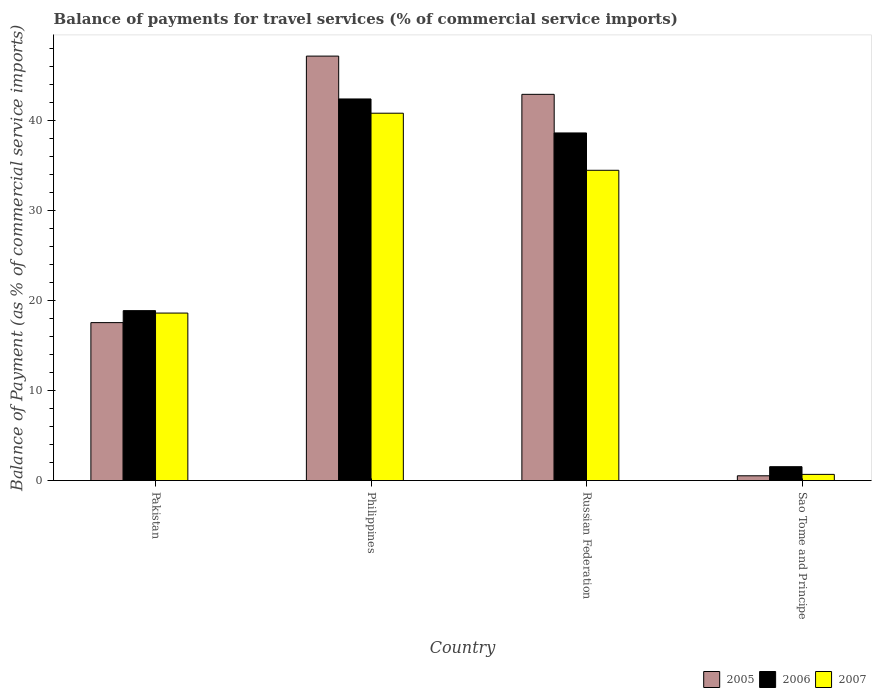How many different coloured bars are there?
Provide a short and direct response. 3. How many groups of bars are there?
Ensure brevity in your answer.  4. How many bars are there on the 4th tick from the left?
Offer a very short reply. 3. What is the label of the 1st group of bars from the left?
Give a very brief answer. Pakistan. In how many cases, is the number of bars for a given country not equal to the number of legend labels?
Your answer should be compact. 0. What is the balance of payments for travel services in 2007 in Russian Federation?
Ensure brevity in your answer.  34.5. Across all countries, what is the maximum balance of payments for travel services in 2007?
Ensure brevity in your answer.  40.84. Across all countries, what is the minimum balance of payments for travel services in 2006?
Keep it short and to the point. 1.54. In which country was the balance of payments for travel services in 2006 maximum?
Your answer should be very brief. Philippines. In which country was the balance of payments for travel services in 2007 minimum?
Make the answer very short. Sao Tome and Principe. What is the total balance of payments for travel services in 2005 in the graph?
Make the answer very short. 108.24. What is the difference between the balance of payments for travel services in 2006 in Pakistan and that in Sao Tome and Principe?
Ensure brevity in your answer.  17.35. What is the difference between the balance of payments for travel services in 2005 in Sao Tome and Principe and the balance of payments for travel services in 2006 in Russian Federation?
Your answer should be very brief. -38.12. What is the average balance of payments for travel services in 2006 per country?
Your answer should be compact. 25.38. What is the difference between the balance of payments for travel services of/in 2005 and balance of payments for travel services of/in 2006 in Sao Tome and Principe?
Make the answer very short. -1.01. What is the ratio of the balance of payments for travel services in 2005 in Philippines to that in Sao Tome and Principe?
Provide a short and direct response. 88.75. Is the balance of payments for travel services in 2007 in Russian Federation less than that in Sao Tome and Principe?
Your answer should be compact. No. What is the difference between the highest and the second highest balance of payments for travel services in 2007?
Your answer should be compact. 6.35. What is the difference between the highest and the lowest balance of payments for travel services in 2006?
Your answer should be compact. 40.89. Is the sum of the balance of payments for travel services in 2007 in Pakistan and Sao Tome and Principe greater than the maximum balance of payments for travel services in 2005 across all countries?
Offer a very short reply. No. Is it the case that in every country, the sum of the balance of payments for travel services in 2007 and balance of payments for travel services in 2005 is greater than the balance of payments for travel services in 2006?
Provide a short and direct response. No. How many bars are there?
Ensure brevity in your answer.  12. How many countries are there in the graph?
Provide a short and direct response. 4. Does the graph contain any zero values?
Your answer should be very brief. No. Does the graph contain grids?
Ensure brevity in your answer.  No. How many legend labels are there?
Keep it short and to the point. 3. How are the legend labels stacked?
Keep it short and to the point. Horizontal. What is the title of the graph?
Give a very brief answer. Balance of payments for travel services (% of commercial service imports). What is the label or title of the X-axis?
Offer a terse response. Country. What is the label or title of the Y-axis?
Offer a very short reply. Balance of Payment (as % of commercial service imports). What is the Balance of Payment (as % of commercial service imports) of 2005 in Pakistan?
Your answer should be very brief. 17.56. What is the Balance of Payment (as % of commercial service imports) in 2006 in Pakistan?
Give a very brief answer. 18.89. What is the Balance of Payment (as % of commercial service imports) in 2007 in Pakistan?
Provide a short and direct response. 18.62. What is the Balance of Payment (as % of commercial service imports) in 2005 in Philippines?
Your response must be concise. 47.2. What is the Balance of Payment (as % of commercial service imports) in 2006 in Philippines?
Your answer should be very brief. 42.43. What is the Balance of Payment (as % of commercial service imports) in 2007 in Philippines?
Keep it short and to the point. 40.84. What is the Balance of Payment (as % of commercial service imports) of 2005 in Russian Federation?
Your response must be concise. 42.94. What is the Balance of Payment (as % of commercial service imports) of 2006 in Russian Federation?
Make the answer very short. 38.65. What is the Balance of Payment (as % of commercial service imports) of 2007 in Russian Federation?
Provide a succinct answer. 34.5. What is the Balance of Payment (as % of commercial service imports) in 2005 in Sao Tome and Principe?
Offer a very short reply. 0.53. What is the Balance of Payment (as % of commercial service imports) in 2006 in Sao Tome and Principe?
Provide a short and direct response. 1.54. What is the Balance of Payment (as % of commercial service imports) in 2007 in Sao Tome and Principe?
Provide a short and direct response. 0.69. Across all countries, what is the maximum Balance of Payment (as % of commercial service imports) in 2005?
Keep it short and to the point. 47.2. Across all countries, what is the maximum Balance of Payment (as % of commercial service imports) in 2006?
Make the answer very short. 42.43. Across all countries, what is the maximum Balance of Payment (as % of commercial service imports) of 2007?
Offer a very short reply. 40.84. Across all countries, what is the minimum Balance of Payment (as % of commercial service imports) of 2005?
Offer a terse response. 0.53. Across all countries, what is the minimum Balance of Payment (as % of commercial service imports) of 2006?
Make the answer very short. 1.54. Across all countries, what is the minimum Balance of Payment (as % of commercial service imports) of 2007?
Offer a terse response. 0.69. What is the total Balance of Payment (as % of commercial service imports) of 2005 in the graph?
Ensure brevity in your answer.  108.23. What is the total Balance of Payment (as % of commercial service imports) in 2006 in the graph?
Offer a very short reply. 101.52. What is the total Balance of Payment (as % of commercial service imports) in 2007 in the graph?
Your response must be concise. 94.66. What is the difference between the Balance of Payment (as % of commercial service imports) in 2005 in Pakistan and that in Philippines?
Provide a succinct answer. -29.63. What is the difference between the Balance of Payment (as % of commercial service imports) of 2006 in Pakistan and that in Philippines?
Keep it short and to the point. -23.54. What is the difference between the Balance of Payment (as % of commercial service imports) in 2007 in Pakistan and that in Philippines?
Offer a very short reply. -22.22. What is the difference between the Balance of Payment (as % of commercial service imports) in 2005 in Pakistan and that in Russian Federation?
Your response must be concise. -25.38. What is the difference between the Balance of Payment (as % of commercial service imports) of 2006 in Pakistan and that in Russian Federation?
Provide a short and direct response. -19.76. What is the difference between the Balance of Payment (as % of commercial service imports) in 2007 in Pakistan and that in Russian Federation?
Your answer should be compact. -15.88. What is the difference between the Balance of Payment (as % of commercial service imports) of 2005 in Pakistan and that in Sao Tome and Principe?
Give a very brief answer. 17.03. What is the difference between the Balance of Payment (as % of commercial service imports) of 2006 in Pakistan and that in Sao Tome and Principe?
Provide a short and direct response. 17.35. What is the difference between the Balance of Payment (as % of commercial service imports) in 2007 in Pakistan and that in Sao Tome and Principe?
Your response must be concise. 17.94. What is the difference between the Balance of Payment (as % of commercial service imports) in 2005 in Philippines and that in Russian Federation?
Offer a terse response. 4.25. What is the difference between the Balance of Payment (as % of commercial service imports) of 2006 in Philippines and that in Russian Federation?
Make the answer very short. 3.78. What is the difference between the Balance of Payment (as % of commercial service imports) in 2007 in Philippines and that in Russian Federation?
Your answer should be compact. 6.35. What is the difference between the Balance of Payment (as % of commercial service imports) in 2005 in Philippines and that in Sao Tome and Principe?
Keep it short and to the point. 46.66. What is the difference between the Balance of Payment (as % of commercial service imports) in 2006 in Philippines and that in Sao Tome and Principe?
Offer a very short reply. 40.89. What is the difference between the Balance of Payment (as % of commercial service imports) in 2007 in Philippines and that in Sao Tome and Principe?
Keep it short and to the point. 40.16. What is the difference between the Balance of Payment (as % of commercial service imports) in 2005 in Russian Federation and that in Sao Tome and Principe?
Ensure brevity in your answer.  42.41. What is the difference between the Balance of Payment (as % of commercial service imports) of 2006 in Russian Federation and that in Sao Tome and Principe?
Offer a terse response. 37.11. What is the difference between the Balance of Payment (as % of commercial service imports) of 2007 in Russian Federation and that in Sao Tome and Principe?
Ensure brevity in your answer.  33.81. What is the difference between the Balance of Payment (as % of commercial service imports) in 2005 in Pakistan and the Balance of Payment (as % of commercial service imports) in 2006 in Philippines?
Keep it short and to the point. -24.87. What is the difference between the Balance of Payment (as % of commercial service imports) in 2005 in Pakistan and the Balance of Payment (as % of commercial service imports) in 2007 in Philippines?
Make the answer very short. -23.28. What is the difference between the Balance of Payment (as % of commercial service imports) of 2006 in Pakistan and the Balance of Payment (as % of commercial service imports) of 2007 in Philippines?
Keep it short and to the point. -21.95. What is the difference between the Balance of Payment (as % of commercial service imports) in 2005 in Pakistan and the Balance of Payment (as % of commercial service imports) in 2006 in Russian Federation?
Provide a succinct answer. -21.09. What is the difference between the Balance of Payment (as % of commercial service imports) of 2005 in Pakistan and the Balance of Payment (as % of commercial service imports) of 2007 in Russian Federation?
Offer a very short reply. -16.94. What is the difference between the Balance of Payment (as % of commercial service imports) in 2006 in Pakistan and the Balance of Payment (as % of commercial service imports) in 2007 in Russian Federation?
Your answer should be compact. -15.61. What is the difference between the Balance of Payment (as % of commercial service imports) of 2005 in Pakistan and the Balance of Payment (as % of commercial service imports) of 2006 in Sao Tome and Principe?
Your answer should be compact. 16.02. What is the difference between the Balance of Payment (as % of commercial service imports) in 2005 in Pakistan and the Balance of Payment (as % of commercial service imports) in 2007 in Sao Tome and Principe?
Provide a succinct answer. 16.87. What is the difference between the Balance of Payment (as % of commercial service imports) in 2006 in Pakistan and the Balance of Payment (as % of commercial service imports) in 2007 in Sao Tome and Principe?
Provide a succinct answer. 18.21. What is the difference between the Balance of Payment (as % of commercial service imports) in 2005 in Philippines and the Balance of Payment (as % of commercial service imports) in 2006 in Russian Federation?
Your answer should be compact. 8.54. What is the difference between the Balance of Payment (as % of commercial service imports) of 2005 in Philippines and the Balance of Payment (as % of commercial service imports) of 2007 in Russian Federation?
Your answer should be compact. 12.7. What is the difference between the Balance of Payment (as % of commercial service imports) in 2006 in Philippines and the Balance of Payment (as % of commercial service imports) in 2007 in Russian Federation?
Keep it short and to the point. 7.93. What is the difference between the Balance of Payment (as % of commercial service imports) in 2005 in Philippines and the Balance of Payment (as % of commercial service imports) in 2006 in Sao Tome and Principe?
Ensure brevity in your answer.  45.65. What is the difference between the Balance of Payment (as % of commercial service imports) of 2005 in Philippines and the Balance of Payment (as % of commercial service imports) of 2007 in Sao Tome and Principe?
Your response must be concise. 46.51. What is the difference between the Balance of Payment (as % of commercial service imports) in 2006 in Philippines and the Balance of Payment (as % of commercial service imports) in 2007 in Sao Tome and Principe?
Keep it short and to the point. 41.74. What is the difference between the Balance of Payment (as % of commercial service imports) in 2005 in Russian Federation and the Balance of Payment (as % of commercial service imports) in 2006 in Sao Tome and Principe?
Your answer should be compact. 41.4. What is the difference between the Balance of Payment (as % of commercial service imports) in 2005 in Russian Federation and the Balance of Payment (as % of commercial service imports) in 2007 in Sao Tome and Principe?
Offer a terse response. 42.26. What is the difference between the Balance of Payment (as % of commercial service imports) in 2006 in Russian Federation and the Balance of Payment (as % of commercial service imports) in 2007 in Sao Tome and Principe?
Ensure brevity in your answer.  37.96. What is the average Balance of Payment (as % of commercial service imports) in 2005 per country?
Provide a short and direct response. 27.06. What is the average Balance of Payment (as % of commercial service imports) in 2006 per country?
Keep it short and to the point. 25.38. What is the average Balance of Payment (as % of commercial service imports) in 2007 per country?
Give a very brief answer. 23.66. What is the difference between the Balance of Payment (as % of commercial service imports) of 2005 and Balance of Payment (as % of commercial service imports) of 2006 in Pakistan?
Your response must be concise. -1.33. What is the difference between the Balance of Payment (as % of commercial service imports) of 2005 and Balance of Payment (as % of commercial service imports) of 2007 in Pakistan?
Give a very brief answer. -1.06. What is the difference between the Balance of Payment (as % of commercial service imports) in 2006 and Balance of Payment (as % of commercial service imports) in 2007 in Pakistan?
Your response must be concise. 0.27. What is the difference between the Balance of Payment (as % of commercial service imports) of 2005 and Balance of Payment (as % of commercial service imports) of 2006 in Philippines?
Make the answer very short. 4.77. What is the difference between the Balance of Payment (as % of commercial service imports) of 2005 and Balance of Payment (as % of commercial service imports) of 2007 in Philippines?
Provide a short and direct response. 6.35. What is the difference between the Balance of Payment (as % of commercial service imports) in 2006 and Balance of Payment (as % of commercial service imports) in 2007 in Philippines?
Provide a succinct answer. 1.58. What is the difference between the Balance of Payment (as % of commercial service imports) in 2005 and Balance of Payment (as % of commercial service imports) in 2006 in Russian Federation?
Your answer should be compact. 4.29. What is the difference between the Balance of Payment (as % of commercial service imports) of 2005 and Balance of Payment (as % of commercial service imports) of 2007 in Russian Federation?
Offer a terse response. 8.44. What is the difference between the Balance of Payment (as % of commercial service imports) in 2006 and Balance of Payment (as % of commercial service imports) in 2007 in Russian Federation?
Provide a short and direct response. 4.15. What is the difference between the Balance of Payment (as % of commercial service imports) of 2005 and Balance of Payment (as % of commercial service imports) of 2006 in Sao Tome and Principe?
Make the answer very short. -1.01. What is the difference between the Balance of Payment (as % of commercial service imports) in 2005 and Balance of Payment (as % of commercial service imports) in 2007 in Sao Tome and Principe?
Your answer should be very brief. -0.16. What is the difference between the Balance of Payment (as % of commercial service imports) of 2006 and Balance of Payment (as % of commercial service imports) of 2007 in Sao Tome and Principe?
Your answer should be compact. 0.86. What is the ratio of the Balance of Payment (as % of commercial service imports) in 2005 in Pakistan to that in Philippines?
Keep it short and to the point. 0.37. What is the ratio of the Balance of Payment (as % of commercial service imports) of 2006 in Pakistan to that in Philippines?
Ensure brevity in your answer.  0.45. What is the ratio of the Balance of Payment (as % of commercial service imports) of 2007 in Pakistan to that in Philippines?
Make the answer very short. 0.46. What is the ratio of the Balance of Payment (as % of commercial service imports) of 2005 in Pakistan to that in Russian Federation?
Give a very brief answer. 0.41. What is the ratio of the Balance of Payment (as % of commercial service imports) in 2006 in Pakistan to that in Russian Federation?
Keep it short and to the point. 0.49. What is the ratio of the Balance of Payment (as % of commercial service imports) of 2007 in Pakistan to that in Russian Federation?
Provide a succinct answer. 0.54. What is the ratio of the Balance of Payment (as % of commercial service imports) in 2005 in Pakistan to that in Sao Tome and Principe?
Your answer should be compact. 33.03. What is the ratio of the Balance of Payment (as % of commercial service imports) of 2006 in Pakistan to that in Sao Tome and Principe?
Offer a very short reply. 12.24. What is the ratio of the Balance of Payment (as % of commercial service imports) of 2007 in Pakistan to that in Sao Tome and Principe?
Offer a terse response. 27.06. What is the ratio of the Balance of Payment (as % of commercial service imports) of 2005 in Philippines to that in Russian Federation?
Keep it short and to the point. 1.1. What is the ratio of the Balance of Payment (as % of commercial service imports) of 2006 in Philippines to that in Russian Federation?
Offer a very short reply. 1.1. What is the ratio of the Balance of Payment (as % of commercial service imports) of 2007 in Philippines to that in Russian Federation?
Your answer should be very brief. 1.18. What is the ratio of the Balance of Payment (as % of commercial service imports) of 2005 in Philippines to that in Sao Tome and Principe?
Keep it short and to the point. 88.75. What is the ratio of the Balance of Payment (as % of commercial service imports) in 2006 in Philippines to that in Sao Tome and Principe?
Your answer should be very brief. 27.49. What is the ratio of the Balance of Payment (as % of commercial service imports) of 2007 in Philippines to that in Sao Tome and Principe?
Give a very brief answer. 59.35. What is the ratio of the Balance of Payment (as % of commercial service imports) of 2005 in Russian Federation to that in Sao Tome and Principe?
Provide a short and direct response. 80.75. What is the ratio of the Balance of Payment (as % of commercial service imports) of 2006 in Russian Federation to that in Sao Tome and Principe?
Keep it short and to the point. 25.04. What is the ratio of the Balance of Payment (as % of commercial service imports) of 2007 in Russian Federation to that in Sao Tome and Principe?
Your answer should be compact. 50.13. What is the difference between the highest and the second highest Balance of Payment (as % of commercial service imports) of 2005?
Your answer should be compact. 4.25. What is the difference between the highest and the second highest Balance of Payment (as % of commercial service imports) in 2006?
Your response must be concise. 3.78. What is the difference between the highest and the second highest Balance of Payment (as % of commercial service imports) in 2007?
Provide a short and direct response. 6.35. What is the difference between the highest and the lowest Balance of Payment (as % of commercial service imports) of 2005?
Ensure brevity in your answer.  46.66. What is the difference between the highest and the lowest Balance of Payment (as % of commercial service imports) in 2006?
Provide a succinct answer. 40.89. What is the difference between the highest and the lowest Balance of Payment (as % of commercial service imports) of 2007?
Provide a succinct answer. 40.16. 